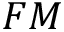<formula> <loc_0><loc_0><loc_500><loc_500>F M</formula> 